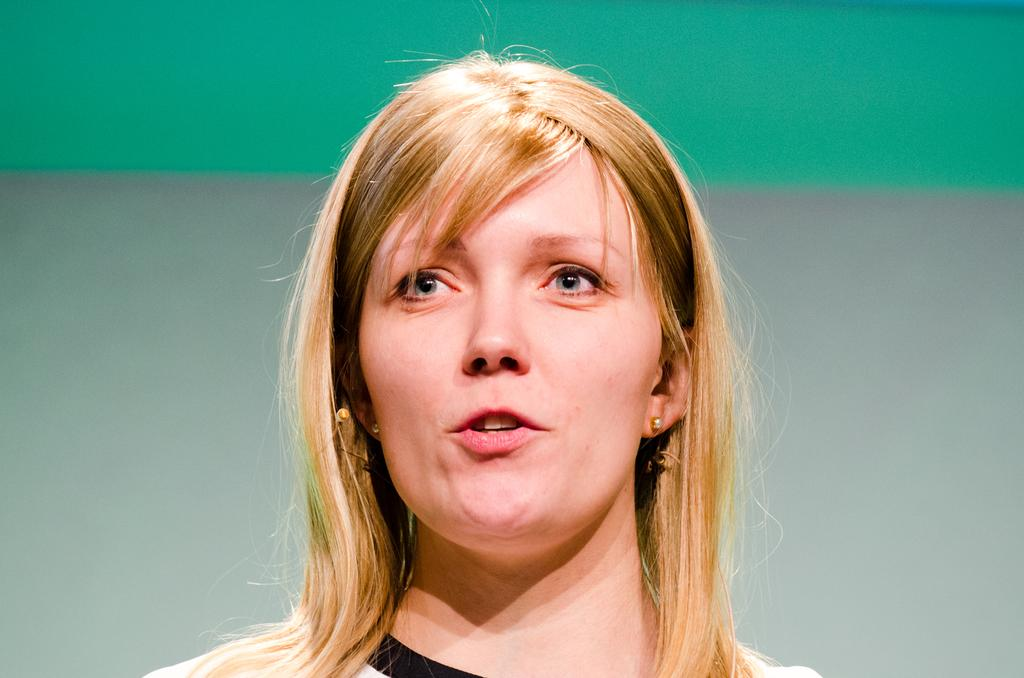Who is present in the image? There is a woman in the image. What is behind the woman in the image? There is a wall behind the woman. What type of bit is the governor using in the image? There is no governor or bit present in the image; it features a woman and a wall. 